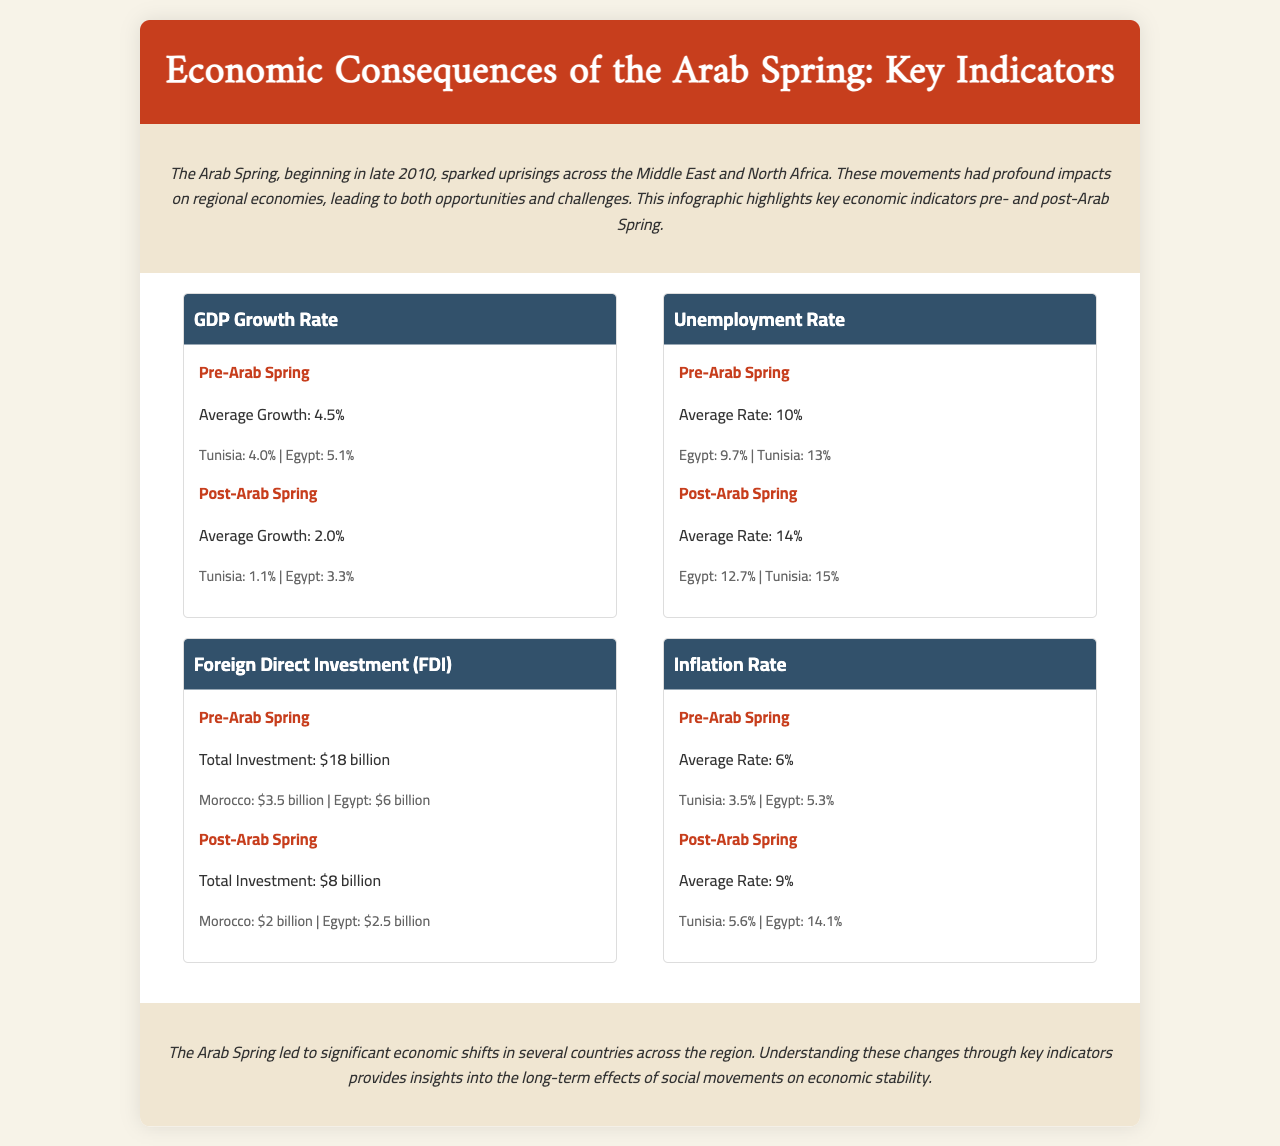What was the average GDP growth rate pre-Arab Spring? The average GDP growth rate before the Arab Spring is found in the "GDP Growth Rate" section under "Pre-Arab Spring."
Answer: 4.5% What was the average unemployment rate post-Arab Spring? The average unemployment rate after the Arab Spring is found in the "Unemployment Rate" section under "Post-Arab Spring."
Answer: 14% Which country had the highestForeign Direct Investment (FDI) before the Arab Spring? The country with the highest FDI before the Arab Spring is specified in the "Foreign Direct Investment (FDI)" section.
Answer: Egypt What was the inflation rate in Tunisia post-Arab Spring? The inflation rate in Tunisia after the Arab Spring is referenced in the "Inflation Rate" section under "Post-Arab Spring."
Answer: 5.6% How much was the total Foreign Direct Investment (FDI) before the Arab Spring? The total FDI amount before the Arab Spring can be found in the "Foreign Direct Investment (FDI)" section under "Pre-Arab Spring."
Answer: $18 billion What economic indicator had the largest decline in average value after the Arab Spring? The economic indicator with the largest decline is identified through a comparison of the pre- and post-Arab Spring values for each indicator.
Answer: GDP Growth Rate What was the inflation rate in Egypt pre-Arab Spring? The inflation rate in Egypt before the Arab Spring is listed in the "Inflation Rate" section under "Pre-Arab Spring."
Answer: 5.3% How many notable countries are mentioned for unemployment rate before the Arab Spring? The number of notable countries under the unemployment rate for pre-Arab Spring is noted by counting the entries in that section.
Answer: 2 